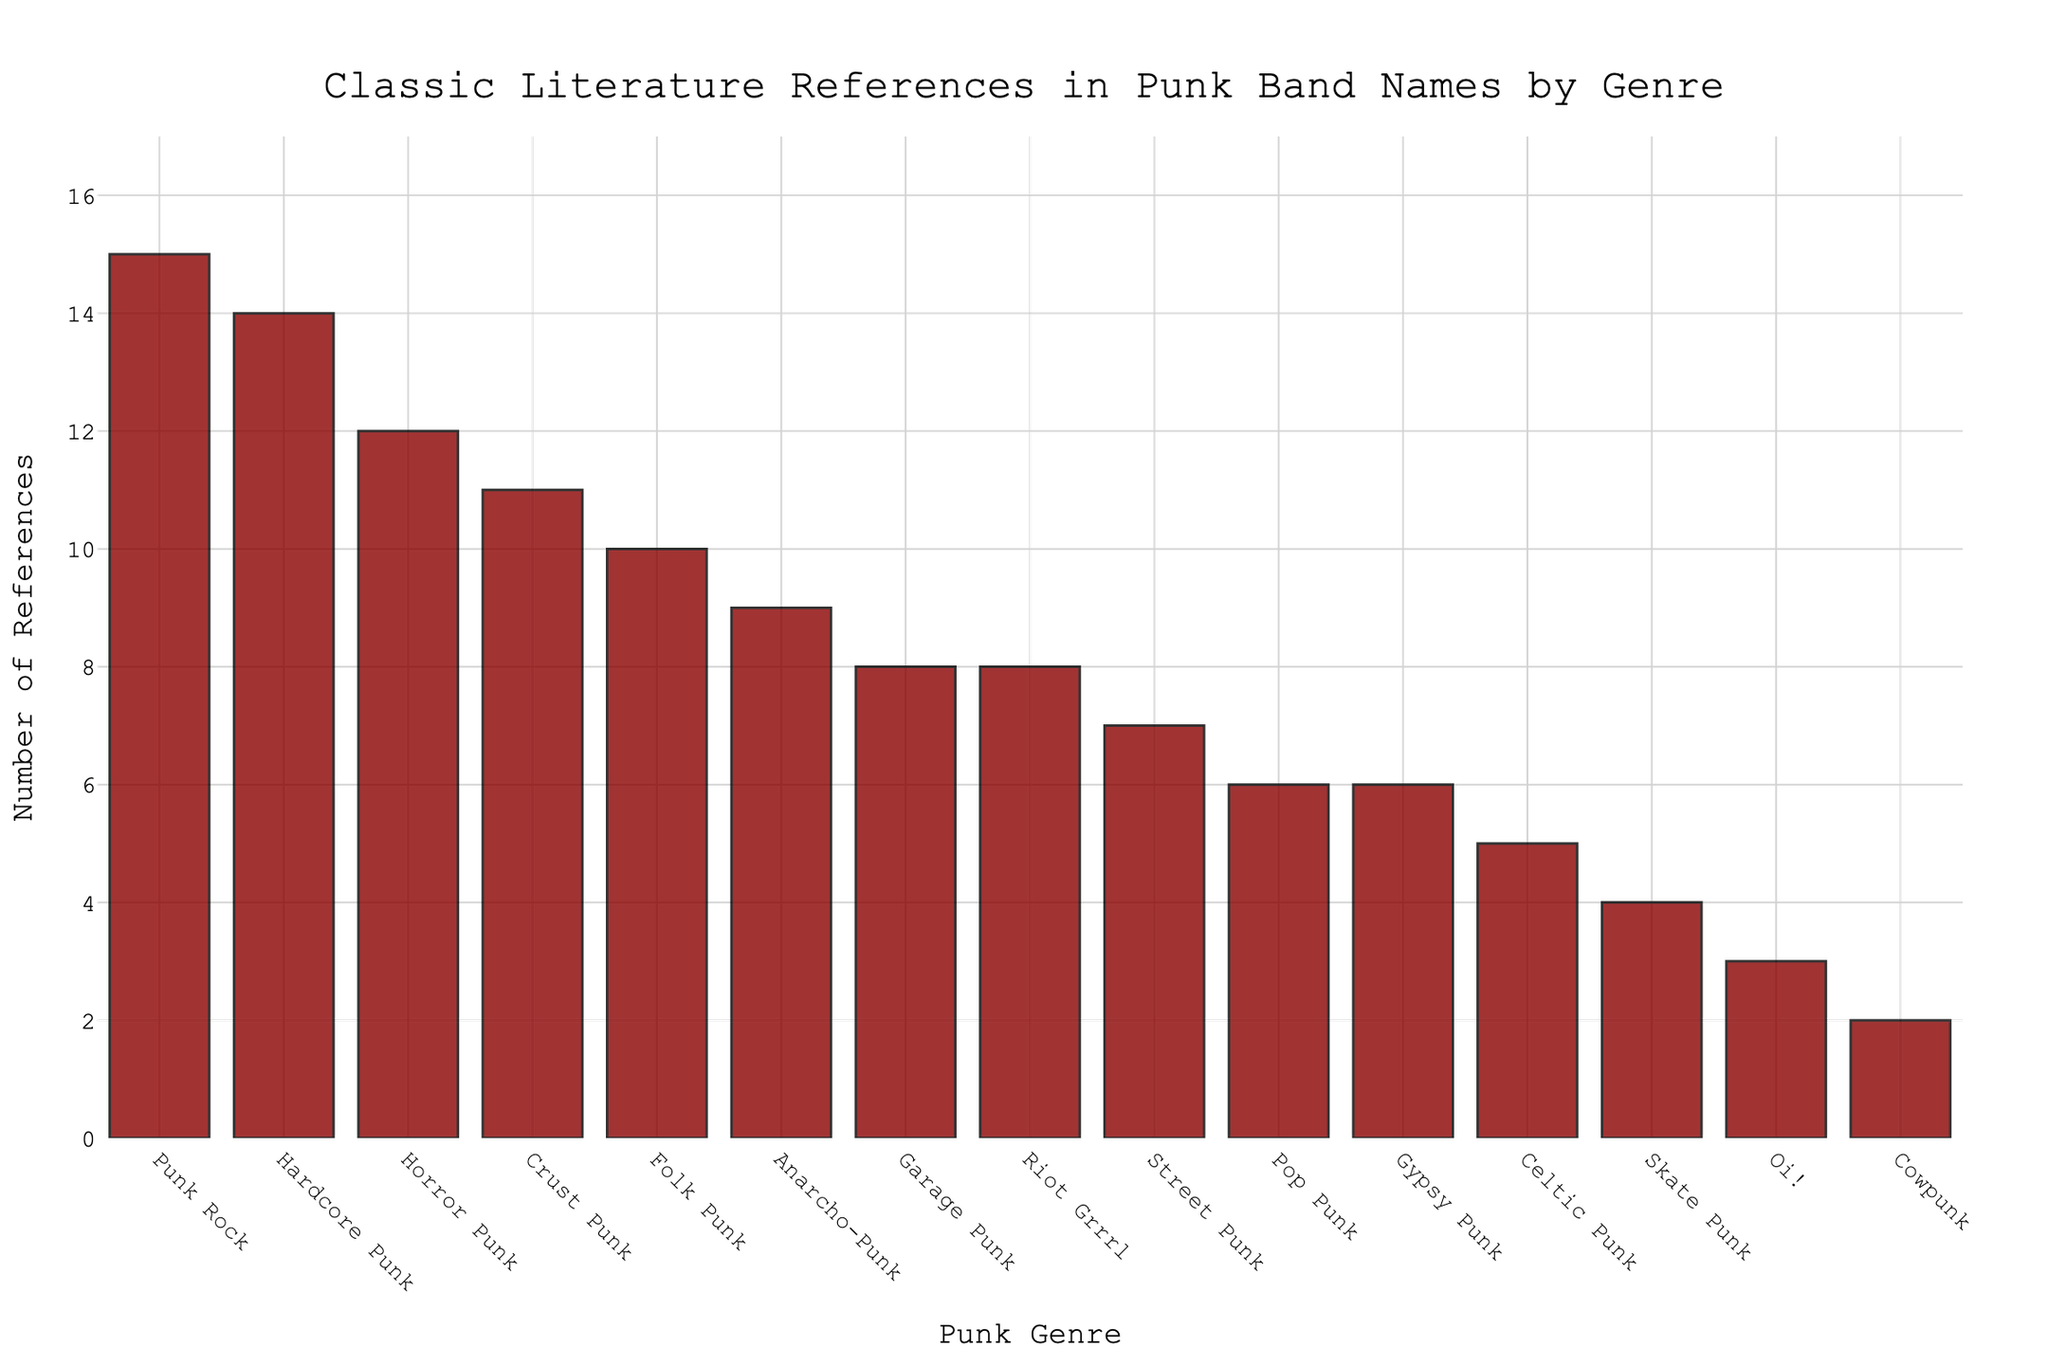Which genre has the most classic literature references? To determine the genre with the most references, we look for the highest bar. The genre associated with the tallest bar on the chart is Punk Rock.
Answer: Punk Rock Which genre has the fewest classic literature references? To find the genre with the fewest references, we look for the shortest bar. The genre related to the shortest bar on the chart is Cowpunk.
Answer: Cowpunk How many more references does Punk Rock have compared to Oi!? Punk Rock has 15 references and Oi! has 3 references. Subtract the references of Oi! from Punk Rock to find the difference: 15 - 3.
Answer: 12 What is the total number of classic literature references for Hardcore Punk, Anarcho-Punk, and Pop Punk combined? Sum the references for Hardcore Punk (14), Anarcho-Punk (9), and Pop Punk (6): 14 + 9 + 6.
Answer: 29 Is the number of references in Horror Punk greater than that in Folk Punk? Compare the number of references in Horror Punk (12) to Folk Punk (10). Since 12 is greater than 10, yes, Horror Punk has more references.
Answer: Yes Which genre has the second-highest number of classic literature references? After identifying Punk Rock as the highest with 15 references, look for the next tallest bar. The genre with the second-highest references is Hardcore Punk with 14 references.
Answer: Hardcore Punk How many genres have more than 10 classic literature references? Count the number of bars with heights above the 10-reference mark. These genres are Punk Rock (15), Hardcore Punk (14), and Horror Punk (12).
Answer: 3 What is the difference in the number of references between Crust Punk and Garage Punk? Crust Punk has 11 references, and Garage Punk has 8 references. Subtract 8 from 11 to find the difference: 11 - 8.
Answer: 3 What is the average number of references among the genres that have fewer than 5 references? The genres with fewer than 5 references are Skate Punk (4), Oi! (3), and Cowpunk (2). Calculate the average: (4 + 3 + 2) / 3.
Answer: 3 How many references in total do the genres in the middle (with 6 to 9 references) have? Sum the references for Anarcho-Punk (9), Folk Punk (10), Garage Punk (8), Street Punk (7), Gypsy Punk (6), Pop Punk (6), and Celtic Punk (5): 9 + 10 + 8 + 7 + 6 + 6 + 5.
Answer: 51 